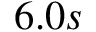<formula> <loc_0><loc_0><loc_500><loc_500>6 . 0 s</formula> 